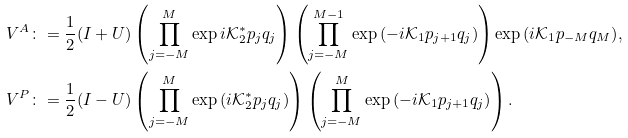Convert formula to latex. <formula><loc_0><loc_0><loc_500><loc_500>V ^ { A } \colon & = \frac { 1 } { 2 } ( I + U ) \left ( \prod _ { j = - M } ^ { M } \exp { i \mathcal { K } ^ { * } _ { 2 } } p _ { j } q _ { j } \right ) \left ( \prod _ { j = - M } ^ { M - 1 } \exp { ( - i \mathcal { K } _ { 1 } p _ { j + 1 } q _ { j } ) } \right ) \exp { ( i \mathcal { K } _ { 1 } p _ { - M } q _ { M } ) } , \\ V ^ { P } \colon & = \frac { 1 } { 2 } ( I - U ) \left ( \prod _ { j = - M } ^ { M } \exp { ( i \mathcal { K } ^ { * } _ { 2 } p _ { j } q _ { j } ) } \right ) \left ( \prod _ { j = - M } ^ { M } \exp { ( - i \mathcal { K } _ { 1 } p _ { j + 1 } q _ { j } ) } \right ) .</formula> 